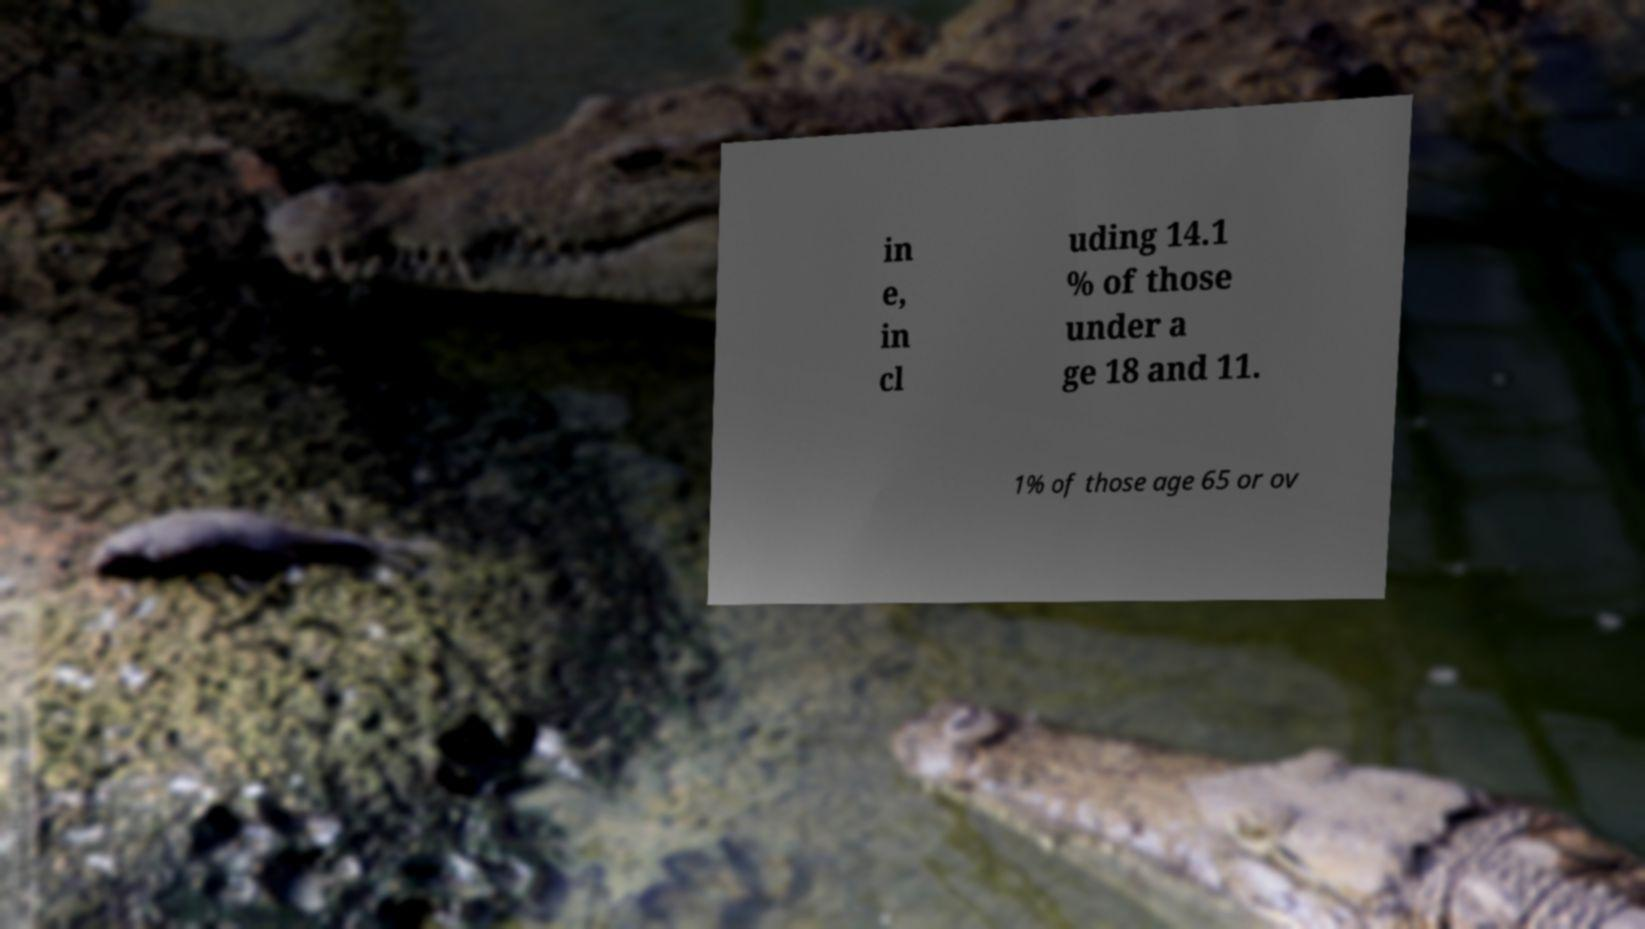Can you read and provide the text displayed in the image?This photo seems to have some interesting text. Can you extract and type it out for me? in e, in cl uding 14.1 % of those under a ge 18 and 11. 1% of those age 65 or ov 